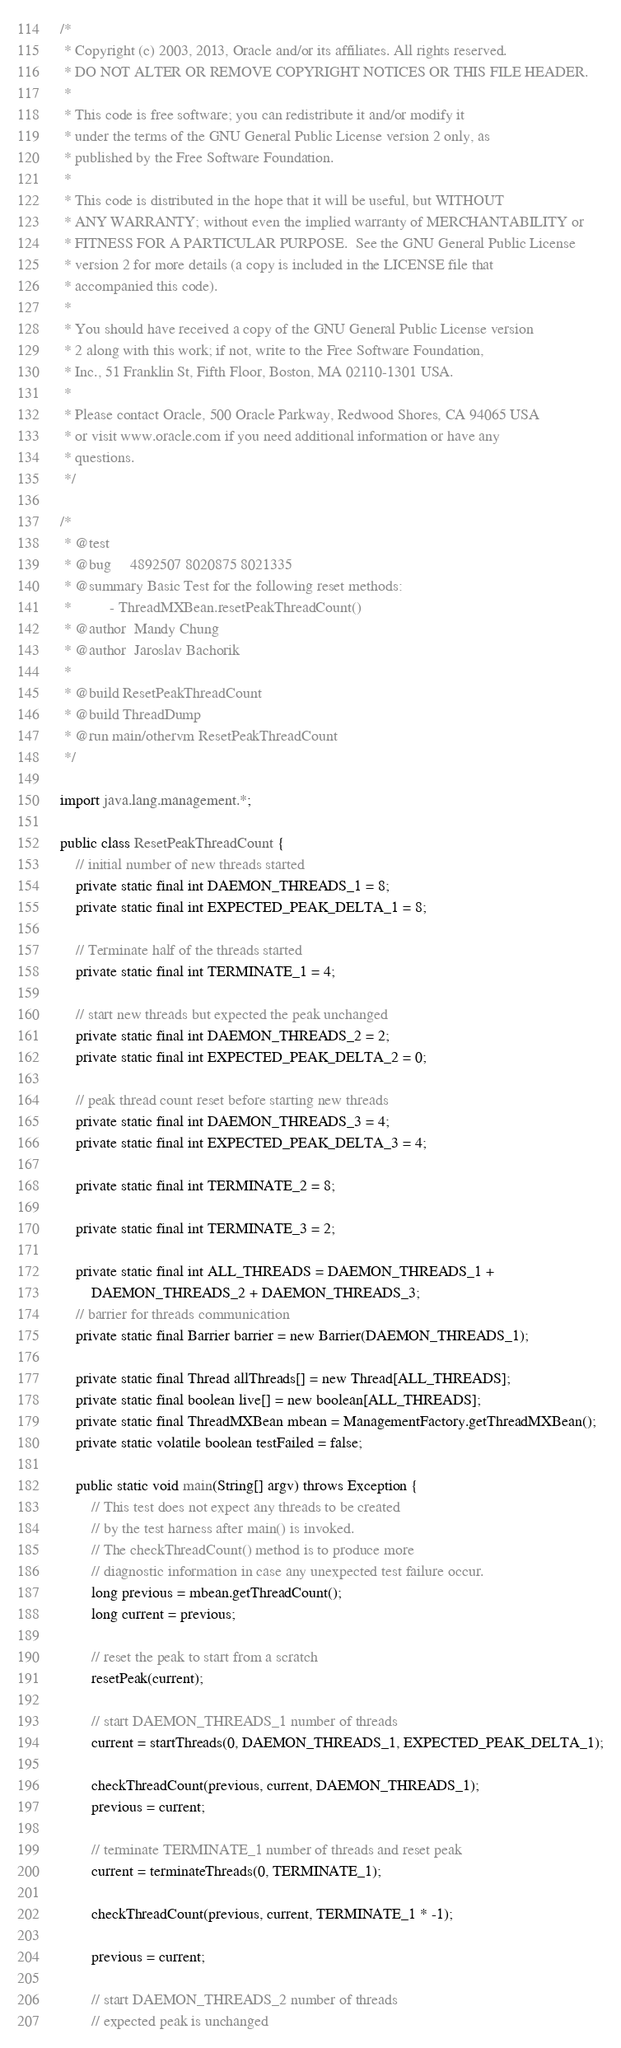Convert code to text. <code><loc_0><loc_0><loc_500><loc_500><_Java_>/*
 * Copyright (c) 2003, 2013, Oracle and/or its affiliates. All rights reserved.
 * DO NOT ALTER OR REMOVE COPYRIGHT NOTICES OR THIS FILE HEADER.
 *
 * This code is free software; you can redistribute it and/or modify it
 * under the terms of the GNU General Public License version 2 only, as
 * published by the Free Software Foundation.
 *
 * This code is distributed in the hope that it will be useful, but WITHOUT
 * ANY WARRANTY; without even the implied warranty of MERCHANTABILITY or
 * FITNESS FOR A PARTICULAR PURPOSE.  See the GNU General Public License
 * version 2 for more details (a copy is included in the LICENSE file that
 * accompanied this code).
 *
 * You should have received a copy of the GNU General Public License version
 * 2 along with this work; if not, write to the Free Software Foundation,
 * Inc., 51 Franklin St, Fifth Floor, Boston, MA 02110-1301 USA.
 *
 * Please contact Oracle, 500 Oracle Parkway, Redwood Shores, CA 94065 USA
 * or visit www.oracle.com if you need additional information or have any
 * questions.
 */

/*
 * @test
 * @bug     4892507 8020875 8021335
 * @summary Basic Test for the following reset methods:
 *          - ThreadMXBean.resetPeakThreadCount()
 * @author  Mandy Chung
 * @author  Jaroslav Bachorik
 *
 * @build ResetPeakThreadCount
 * @build ThreadDump
 * @run main/othervm ResetPeakThreadCount
 */

import java.lang.management.*;

public class ResetPeakThreadCount {
    // initial number of new threads started
    private static final int DAEMON_THREADS_1 = 8;
    private static final int EXPECTED_PEAK_DELTA_1 = 8;

    // Terminate half of the threads started
    private static final int TERMINATE_1 = 4;

    // start new threads but expected the peak unchanged
    private static final int DAEMON_THREADS_2 = 2;
    private static final int EXPECTED_PEAK_DELTA_2 = 0;

    // peak thread count reset before starting new threads
    private static final int DAEMON_THREADS_3 = 4;
    private static final int EXPECTED_PEAK_DELTA_3 = 4;

    private static final int TERMINATE_2 = 8;

    private static final int TERMINATE_3 = 2;

    private static final int ALL_THREADS = DAEMON_THREADS_1 +
        DAEMON_THREADS_2 + DAEMON_THREADS_3;
    // barrier for threads communication
    private static final Barrier barrier = new Barrier(DAEMON_THREADS_1);

    private static final Thread allThreads[] = new Thread[ALL_THREADS];
    private static final boolean live[] = new boolean[ALL_THREADS];
    private static final ThreadMXBean mbean = ManagementFactory.getThreadMXBean();
    private static volatile boolean testFailed = false;

    public static void main(String[] argv) throws Exception {
        // This test does not expect any threads to be created
        // by the test harness after main() is invoked.
        // The checkThreadCount() method is to produce more
        // diagnostic information in case any unexpected test failure occur.
        long previous = mbean.getThreadCount();
        long current = previous;

        // reset the peak to start from a scratch
        resetPeak(current);

        // start DAEMON_THREADS_1 number of threads
        current = startThreads(0, DAEMON_THREADS_1, EXPECTED_PEAK_DELTA_1);

        checkThreadCount(previous, current, DAEMON_THREADS_1);
        previous = current;

        // terminate TERMINATE_1 number of threads and reset peak
        current = terminateThreads(0, TERMINATE_1);

        checkThreadCount(previous, current, TERMINATE_1 * -1);

        previous = current;

        // start DAEMON_THREADS_2 number of threads
        // expected peak is unchanged</code> 